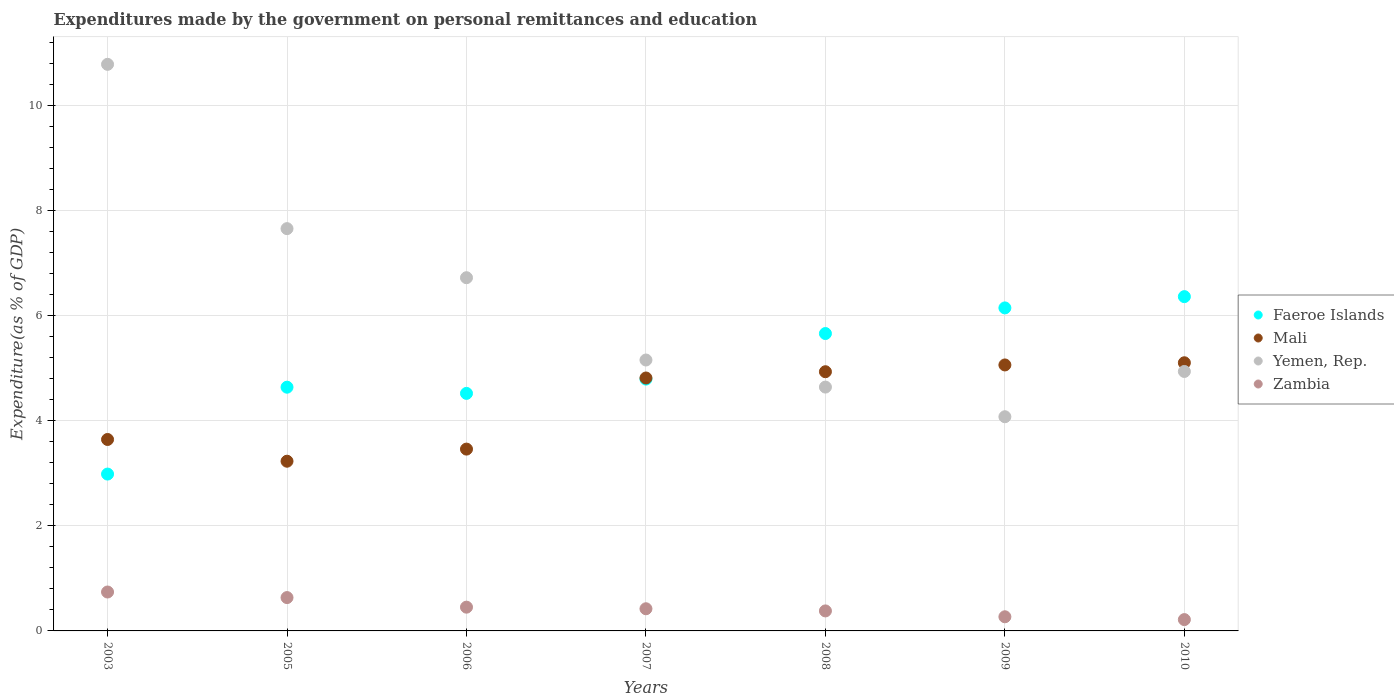Is the number of dotlines equal to the number of legend labels?
Ensure brevity in your answer.  Yes. What is the expenditures made by the government on personal remittances and education in Faeroe Islands in 2010?
Your answer should be very brief. 6.36. Across all years, what is the maximum expenditures made by the government on personal remittances and education in Faeroe Islands?
Give a very brief answer. 6.36. Across all years, what is the minimum expenditures made by the government on personal remittances and education in Zambia?
Make the answer very short. 0.22. In which year was the expenditures made by the government on personal remittances and education in Zambia minimum?
Provide a short and direct response. 2010. What is the total expenditures made by the government on personal remittances and education in Faeroe Islands in the graph?
Offer a terse response. 35.1. What is the difference between the expenditures made by the government on personal remittances and education in Zambia in 2009 and that in 2010?
Keep it short and to the point. 0.05. What is the difference between the expenditures made by the government on personal remittances and education in Faeroe Islands in 2006 and the expenditures made by the government on personal remittances and education in Mali in 2008?
Ensure brevity in your answer.  -0.41. What is the average expenditures made by the government on personal remittances and education in Faeroe Islands per year?
Make the answer very short. 5.01. In the year 2009, what is the difference between the expenditures made by the government on personal remittances and education in Faeroe Islands and expenditures made by the government on personal remittances and education in Yemen, Rep.?
Keep it short and to the point. 2.07. In how many years, is the expenditures made by the government on personal remittances and education in Yemen, Rep. greater than 0.4 %?
Give a very brief answer. 7. What is the ratio of the expenditures made by the government on personal remittances and education in Mali in 2008 to that in 2009?
Provide a succinct answer. 0.97. Is the expenditures made by the government on personal remittances and education in Mali in 2007 less than that in 2008?
Offer a terse response. Yes. Is the difference between the expenditures made by the government on personal remittances and education in Faeroe Islands in 2003 and 2006 greater than the difference between the expenditures made by the government on personal remittances and education in Yemen, Rep. in 2003 and 2006?
Keep it short and to the point. No. What is the difference between the highest and the second highest expenditures made by the government on personal remittances and education in Yemen, Rep.?
Your answer should be very brief. 3.13. What is the difference between the highest and the lowest expenditures made by the government on personal remittances and education in Yemen, Rep.?
Provide a succinct answer. 6.71. Is it the case that in every year, the sum of the expenditures made by the government on personal remittances and education in Mali and expenditures made by the government on personal remittances and education in Yemen, Rep.  is greater than the sum of expenditures made by the government on personal remittances and education in Faeroe Islands and expenditures made by the government on personal remittances and education in Zambia?
Provide a short and direct response. No. Is it the case that in every year, the sum of the expenditures made by the government on personal remittances and education in Faeroe Islands and expenditures made by the government on personal remittances and education in Zambia  is greater than the expenditures made by the government on personal remittances and education in Yemen, Rep.?
Keep it short and to the point. No. Does the expenditures made by the government on personal remittances and education in Mali monotonically increase over the years?
Make the answer very short. No. Is the expenditures made by the government on personal remittances and education in Faeroe Islands strictly greater than the expenditures made by the government on personal remittances and education in Zambia over the years?
Provide a short and direct response. Yes. How many dotlines are there?
Provide a succinct answer. 4. How many years are there in the graph?
Give a very brief answer. 7. What is the difference between two consecutive major ticks on the Y-axis?
Provide a succinct answer. 2. Does the graph contain any zero values?
Your response must be concise. No. Where does the legend appear in the graph?
Provide a short and direct response. Center right. How are the legend labels stacked?
Make the answer very short. Vertical. What is the title of the graph?
Make the answer very short. Expenditures made by the government on personal remittances and education. Does "Netherlands" appear as one of the legend labels in the graph?
Your answer should be compact. No. What is the label or title of the X-axis?
Provide a short and direct response. Years. What is the label or title of the Y-axis?
Keep it short and to the point. Expenditure(as % of GDP). What is the Expenditure(as % of GDP) of Faeroe Islands in 2003?
Give a very brief answer. 2.98. What is the Expenditure(as % of GDP) of Mali in 2003?
Your answer should be very brief. 3.64. What is the Expenditure(as % of GDP) of Yemen, Rep. in 2003?
Provide a short and direct response. 10.78. What is the Expenditure(as % of GDP) in Zambia in 2003?
Your answer should be compact. 0.74. What is the Expenditure(as % of GDP) of Faeroe Islands in 2005?
Offer a very short reply. 4.64. What is the Expenditure(as % of GDP) in Mali in 2005?
Offer a terse response. 3.23. What is the Expenditure(as % of GDP) of Yemen, Rep. in 2005?
Your answer should be compact. 7.66. What is the Expenditure(as % of GDP) in Zambia in 2005?
Provide a short and direct response. 0.63. What is the Expenditure(as % of GDP) of Faeroe Islands in 2006?
Keep it short and to the point. 4.52. What is the Expenditure(as % of GDP) in Mali in 2006?
Ensure brevity in your answer.  3.46. What is the Expenditure(as % of GDP) of Yemen, Rep. in 2006?
Offer a terse response. 6.72. What is the Expenditure(as % of GDP) of Zambia in 2006?
Provide a succinct answer. 0.45. What is the Expenditure(as % of GDP) of Faeroe Islands in 2007?
Provide a succinct answer. 4.79. What is the Expenditure(as % of GDP) of Mali in 2007?
Ensure brevity in your answer.  4.81. What is the Expenditure(as % of GDP) in Yemen, Rep. in 2007?
Your answer should be very brief. 5.16. What is the Expenditure(as % of GDP) of Zambia in 2007?
Ensure brevity in your answer.  0.42. What is the Expenditure(as % of GDP) of Faeroe Islands in 2008?
Offer a very short reply. 5.66. What is the Expenditure(as % of GDP) in Mali in 2008?
Give a very brief answer. 4.93. What is the Expenditure(as % of GDP) in Yemen, Rep. in 2008?
Make the answer very short. 4.64. What is the Expenditure(as % of GDP) in Zambia in 2008?
Give a very brief answer. 0.38. What is the Expenditure(as % of GDP) of Faeroe Islands in 2009?
Your answer should be compact. 6.15. What is the Expenditure(as % of GDP) in Mali in 2009?
Provide a short and direct response. 5.06. What is the Expenditure(as % of GDP) in Yemen, Rep. in 2009?
Make the answer very short. 4.08. What is the Expenditure(as % of GDP) in Zambia in 2009?
Give a very brief answer. 0.27. What is the Expenditure(as % of GDP) of Faeroe Islands in 2010?
Offer a very short reply. 6.36. What is the Expenditure(as % of GDP) of Mali in 2010?
Keep it short and to the point. 5.1. What is the Expenditure(as % of GDP) in Yemen, Rep. in 2010?
Give a very brief answer. 4.94. What is the Expenditure(as % of GDP) in Zambia in 2010?
Your answer should be very brief. 0.22. Across all years, what is the maximum Expenditure(as % of GDP) in Faeroe Islands?
Offer a very short reply. 6.36. Across all years, what is the maximum Expenditure(as % of GDP) of Mali?
Your response must be concise. 5.1. Across all years, what is the maximum Expenditure(as % of GDP) of Yemen, Rep.?
Make the answer very short. 10.78. Across all years, what is the maximum Expenditure(as % of GDP) in Zambia?
Make the answer very short. 0.74. Across all years, what is the minimum Expenditure(as % of GDP) of Faeroe Islands?
Your answer should be compact. 2.98. Across all years, what is the minimum Expenditure(as % of GDP) of Mali?
Your answer should be very brief. 3.23. Across all years, what is the minimum Expenditure(as % of GDP) in Yemen, Rep.?
Ensure brevity in your answer.  4.08. Across all years, what is the minimum Expenditure(as % of GDP) in Zambia?
Offer a very short reply. 0.22. What is the total Expenditure(as % of GDP) in Faeroe Islands in the graph?
Offer a terse response. 35.1. What is the total Expenditure(as % of GDP) in Mali in the graph?
Offer a very short reply. 30.24. What is the total Expenditure(as % of GDP) in Yemen, Rep. in the graph?
Offer a very short reply. 43.97. What is the total Expenditure(as % of GDP) of Zambia in the graph?
Offer a very short reply. 3.11. What is the difference between the Expenditure(as % of GDP) in Faeroe Islands in 2003 and that in 2005?
Offer a very short reply. -1.65. What is the difference between the Expenditure(as % of GDP) in Mali in 2003 and that in 2005?
Your answer should be compact. 0.41. What is the difference between the Expenditure(as % of GDP) in Yemen, Rep. in 2003 and that in 2005?
Your answer should be compact. 3.13. What is the difference between the Expenditure(as % of GDP) of Zambia in 2003 and that in 2005?
Your answer should be very brief. 0.11. What is the difference between the Expenditure(as % of GDP) of Faeroe Islands in 2003 and that in 2006?
Keep it short and to the point. -1.54. What is the difference between the Expenditure(as % of GDP) of Mali in 2003 and that in 2006?
Make the answer very short. 0.18. What is the difference between the Expenditure(as % of GDP) in Yemen, Rep. in 2003 and that in 2006?
Give a very brief answer. 4.06. What is the difference between the Expenditure(as % of GDP) of Zambia in 2003 and that in 2006?
Give a very brief answer. 0.29. What is the difference between the Expenditure(as % of GDP) of Faeroe Islands in 2003 and that in 2007?
Provide a succinct answer. -1.81. What is the difference between the Expenditure(as % of GDP) in Mali in 2003 and that in 2007?
Give a very brief answer. -1.17. What is the difference between the Expenditure(as % of GDP) of Yemen, Rep. in 2003 and that in 2007?
Give a very brief answer. 5.63. What is the difference between the Expenditure(as % of GDP) in Zambia in 2003 and that in 2007?
Provide a succinct answer. 0.32. What is the difference between the Expenditure(as % of GDP) in Faeroe Islands in 2003 and that in 2008?
Give a very brief answer. -2.67. What is the difference between the Expenditure(as % of GDP) in Mali in 2003 and that in 2008?
Your answer should be very brief. -1.29. What is the difference between the Expenditure(as % of GDP) of Yemen, Rep. in 2003 and that in 2008?
Your response must be concise. 6.14. What is the difference between the Expenditure(as % of GDP) in Zambia in 2003 and that in 2008?
Provide a succinct answer. 0.36. What is the difference between the Expenditure(as % of GDP) in Faeroe Islands in 2003 and that in 2009?
Ensure brevity in your answer.  -3.16. What is the difference between the Expenditure(as % of GDP) of Mali in 2003 and that in 2009?
Give a very brief answer. -1.42. What is the difference between the Expenditure(as % of GDP) of Yemen, Rep. in 2003 and that in 2009?
Offer a very short reply. 6.71. What is the difference between the Expenditure(as % of GDP) in Zambia in 2003 and that in 2009?
Offer a terse response. 0.47. What is the difference between the Expenditure(as % of GDP) of Faeroe Islands in 2003 and that in 2010?
Give a very brief answer. -3.38. What is the difference between the Expenditure(as % of GDP) of Mali in 2003 and that in 2010?
Ensure brevity in your answer.  -1.46. What is the difference between the Expenditure(as % of GDP) in Yemen, Rep. in 2003 and that in 2010?
Offer a terse response. 5.84. What is the difference between the Expenditure(as % of GDP) of Zambia in 2003 and that in 2010?
Offer a terse response. 0.53. What is the difference between the Expenditure(as % of GDP) in Faeroe Islands in 2005 and that in 2006?
Offer a very short reply. 0.12. What is the difference between the Expenditure(as % of GDP) in Mali in 2005 and that in 2006?
Ensure brevity in your answer.  -0.23. What is the difference between the Expenditure(as % of GDP) of Yemen, Rep. in 2005 and that in 2006?
Offer a terse response. 0.93. What is the difference between the Expenditure(as % of GDP) in Zambia in 2005 and that in 2006?
Your answer should be compact. 0.18. What is the difference between the Expenditure(as % of GDP) of Faeroe Islands in 2005 and that in 2007?
Your answer should be very brief. -0.15. What is the difference between the Expenditure(as % of GDP) in Mali in 2005 and that in 2007?
Offer a terse response. -1.58. What is the difference between the Expenditure(as % of GDP) in Yemen, Rep. in 2005 and that in 2007?
Offer a very short reply. 2.5. What is the difference between the Expenditure(as % of GDP) of Zambia in 2005 and that in 2007?
Make the answer very short. 0.21. What is the difference between the Expenditure(as % of GDP) of Faeroe Islands in 2005 and that in 2008?
Offer a very short reply. -1.02. What is the difference between the Expenditure(as % of GDP) in Mali in 2005 and that in 2008?
Offer a terse response. -1.7. What is the difference between the Expenditure(as % of GDP) of Yemen, Rep. in 2005 and that in 2008?
Give a very brief answer. 3.02. What is the difference between the Expenditure(as % of GDP) in Zambia in 2005 and that in 2008?
Offer a very short reply. 0.25. What is the difference between the Expenditure(as % of GDP) of Faeroe Islands in 2005 and that in 2009?
Ensure brevity in your answer.  -1.51. What is the difference between the Expenditure(as % of GDP) in Mali in 2005 and that in 2009?
Offer a terse response. -1.83. What is the difference between the Expenditure(as % of GDP) in Yemen, Rep. in 2005 and that in 2009?
Make the answer very short. 3.58. What is the difference between the Expenditure(as % of GDP) of Zambia in 2005 and that in 2009?
Make the answer very short. 0.37. What is the difference between the Expenditure(as % of GDP) in Faeroe Islands in 2005 and that in 2010?
Your answer should be compact. -1.72. What is the difference between the Expenditure(as % of GDP) of Mali in 2005 and that in 2010?
Give a very brief answer. -1.87. What is the difference between the Expenditure(as % of GDP) of Yemen, Rep. in 2005 and that in 2010?
Ensure brevity in your answer.  2.72. What is the difference between the Expenditure(as % of GDP) of Zambia in 2005 and that in 2010?
Your answer should be compact. 0.42. What is the difference between the Expenditure(as % of GDP) of Faeroe Islands in 2006 and that in 2007?
Keep it short and to the point. -0.27. What is the difference between the Expenditure(as % of GDP) of Mali in 2006 and that in 2007?
Offer a very short reply. -1.35. What is the difference between the Expenditure(as % of GDP) in Yemen, Rep. in 2006 and that in 2007?
Give a very brief answer. 1.57. What is the difference between the Expenditure(as % of GDP) in Zambia in 2006 and that in 2007?
Your answer should be very brief. 0.03. What is the difference between the Expenditure(as % of GDP) of Faeroe Islands in 2006 and that in 2008?
Give a very brief answer. -1.14. What is the difference between the Expenditure(as % of GDP) in Mali in 2006 and that in 2008?
Provide a short and direct response. -1.47. What is the difference between the Expenditure(as % of GDP) of Yemen, Rep. in 2006 and that in 2008?
Your response must be concise. 2.08. What is the difference between the Expenditure(as % of GDP) of Zambia in 2006 and that in 2008?
Offer a terse response. 0.07. What is the difference between the Expenditure(as % of GDP) of Faeroe Islands in 2006 and that in 2009?
Provide a succinct answer. -1.63. What is the difference between the Expenditure(as % of GDP) in Mali in 2006 and that in 2009?
Your answer should be very brief. -1.6. What is the difference between the Expenditure(as % of GDP) in Yemen, Rep. in 2006 and that in 2009?
Ensure brevity in your answer.  2.65. What is the difference between the Expenditure(as % of GDP) of Zambia in 2006 and that in 2009?
Your response must be concise. 0.18. What is the difference between the Expenditure(as % of GDP) in Faeroe Islands in 2006 and that in 2010?
Ensure brevity in your answer.  -1.84. What is the difference between the Expenditure(as % of GDP) of Mali in 2006 and that in 2010?
Ensure brevity in your answer.  -1.64. What is the difference between the Expenditure(as % of GDP) in Yemen, Rep. in 2006 and that in 2010?
Your answer should be very brief. 1.78. What is the difference between the Expenditure(as % of GDP) of Zambia in 2006 and that in 2010?
Provide a short and direct response. 0.24. What is the difference between the Expenditure(as % of GDP) of Faeroe Islands in 2007 and that in 2008?
Ensure brevity in your answer.  -0.87. What is the difference between the Expenditure(as % of GDP) in Mali in 2007 and that in 2008?
Offer a terse response. -0.12. What is the difference between the Expenditure(as % of GDP) in Yemen, Rep. in 2007 and that in 2008?
Ensure brevity in your answer.  0.52. What is the difference between the Expenditure(as % of GDP) of Zambia in 2007 and that in 2008?
Give a very brief answer. 0.04. What is the difference between the Expenditure(as % of GDP) in Faeroe Islands in 2007 and that in 2009?
Your answer should be very brief. -1.35. What is the difference between the Expenditure(as % of GDP) of Mali in 2007 and that in 2009?
Ensure brevity in your answer.  -0.25. What is the difference between the Expenditure(as % of GDP) of Yemen, Rep. in 2007 and that in 2009?
Your answer should be very brief. 1.08. What is the difference between the Expenditure(as % of GDP) of Zambia in 2007 and that in 2009?
Ensure brevity in your answer.  0.15. What is the difference between the Expenditure(as % of GDP) in Faeroe Islands in 2007 and that in 2010?
Provide a short and direct response. -1.57. What is the difference between the Expenditure(as % of GDP) in Mali in 2007 and that in 2010?
Provide a succinct answer. -0.29. What is the difference between the Expenditure(as % of GDP) of Yemen, Rep. in 2007 and that in 2010?
Your answer should be very brief. 0.22. What is the difference between the Expenditure(as % of GDP) in Zambia in 2007 and that in 2010?
Make the answer very short. 0.21. What is the difference between the Expenditure(as % of GDP) of Faeroe Islands in 2008 and that in 2009?
Ensure brevity in your answer.  -0.49. What is the difference between the Expenditure(as % of GDP) in Mali in 2008 and that in 2009?
Give a very brief answer. -0.13. What is the difference between the Expenditure(as % of GDP) in Yemen, Rep. in 2008 and that in 2009?
Provide a succinct answer. 0.56. What is the difference between the Expenditure(as % of GDP) in Zambia in 2008 and that in 2009?
Offer a terse response. 0.11. What is the difference between the Expenditure(as % of GDP) in Faeroe Islands in 2008 and that in 2010?
Ensure brevity in your answer.  -0.7. What is the difference between the Expenditure(as % of GDP) in Mali in 2008 and that in 2010?
Provide a succinct answer. -0.17. What is the difference between the Expenditure(as % of GDP) of Yemen, Rep. in 2008 and that in 2010?
Your response must be concise. -0.3. What is the difference between the Expenditure(as % of GDP) of Zambia in 2008 and that in 2010?
Provide a short and direct response. 0.17. What is the difference between the Expenditure(as % of GDP) in Faeroe Islands in 2009 and that in 2010?
Give a very brief answer. -0.21. What is the difference between the Expenditure(as % of GDP) in Mali in 2009 and that in 2010?
Keep it short and to the point. -0.04. What is the difference between the Expenditure(as % of GDP) of Yemen, Rep. in 2009 and that in 2010?
Provide a succinct answer. -0.86. What is the difference between the Expenditure(as % of GDP) in Zambia in 2009 and that in 2010?
Ensure brevity in your answer.  0.05. What is the difference between the Expenditure(as % of GDP) of Faeroe Islands in 2003 and the Expenditure(as % of GDP) of Mali in 2005?
Provide a succinct answer. -0.24. What is the difference between the Expenditure(as % of GDP) of Faeroe Islands in 2003 and the Expenditure(as % of GDP) of Yemen, Rep. in 2005?
Offer a very short reply. -4.67. What is the difference between the Expenditure(as % of GDP) in Faeroe Islands in 2003 and the Expenditure(as % of GDP) in Zambia in 2005?
Keep it short and to the point. 2.35. What is the difference between the Expenditure(as % of GDP) of Mali in 2003 and the Expenditure(as % of GDP) of Yemen, Rep. in 2005?
Your answer should be compact. -4.01. What is the difference between the Expenditure(as % of GDP) in Mali in 2003 and the Expenditure(as % of GDP) in Zambia in 2005?
Offer a terse response. 3.01. What is the difference between the Expenditure(as % of GDP) in Yemen, Rep. in 2003 and the Expenditure(as % of GDP) in Zambia in 2005?
Your answer should be compact. 10.15. What is the difference between the Expenditure(as % of GDP) of Faeroe Islands in 2003 and the Expenditure(as % of GDP) of Mali in 2006?
Ensure brevity in your answer.  -0.48. What is the difference between the Expenditure(as % of GDP) in Faeroe Islands in 2003 and the Expenditure(as % of GDP) in Yemen, Rep. in 2006?
Give a very brief answer. -3.74. What is the difference between the Expenditure(as % of GDP) in Faeroe Islands in 2003 and the Expenditure(as % of GDP) in Zambia in 2006?
Make the answer very short. 2.53. What is the difference between the Expenditure(as % of GDP) in Mali in 2003 and the Expenditure(as % of GDP) in Yemen, Rep. in 2006?
Keep it short and to the point. -3.08. What is the difference between the Expenditure(as % of GDP) of Mali in 2003 and the Expenditure(as % of GDP) of Zambia in 2006?
Give a very brief answer. 3.19. What is the difference between the Expenditure(as % of GDP) in Yemen, Rep. in 2003 and the Expenditure(as % of GDP) in Zambia in 2006?
Keep it short and to the point. 10.33. What is the difference between the Expenditure(as % of GDP) of Faeroe Islands in 2003 and the Expenditure(as % of GDP) of Mali in 2007?
Your response must be concise. -1.83. What is the difference between the Expenditure(as % of GDP) of Faeroe Islands in 2003 and the Expenditure(as % of GDP) of Yemen, Rep. in 2007?
Your answer should be very brief. -2.17. What is the difference between the Expenditure(as % of GDP) in Faeroe Islands in 2003 and the Expenditure(as % of GDP) in Zambia in 2007?
Provide a short and direct response. 2.56. What is the difference between the Expenditure(as % of GDP) of Mali in 2003 and the Expenditure(as % of GDP) of Yemen, Rep. in 2007?
Offer a very short reply. -1.51. What is the difference between the Expenditure(as % of GDP) in Mali in 2003 and the Expenditure(as % of GDP) in Zambia in 2007?
Your response must be concise. 3.22. What is the difference between the Expenditure(as % of GDP) of Yemen, Rep. in 2003 and the Expenditure(as % of GDP) of Zambia in 2007?
Your response must be concise. 10.36. What is the difference between the Expenditure(as % of GDP) of Faeroe Islands in 2003 and the Expenditure(as % of GDP) of Mali in 2008?
Offer a terse response. -1.95. What is the difference between the Expenditure(as % of GDP) in Faeroe Islands in 2003 and the Expenditure(as % of GDP) in Yemen, Rep. in 2008?
Offer a terse response. -1.66. What is the difference between the Expenditure(as % of GDP) in Faeroe Islands in 2003 and the Expenditure(as % of GDP) in Zambia in 2008?
Provide a short and direct response. 2.6. What is the difference between the Expenditure(as % of GDP) in Mali in 2003 and the Expenditure(as % of GDP) in Yemen, Rep. in 2008?
Provide a succinct answer. -1. What is the difference between the Expenditure(as % of GDP) of Mali in 2003 and the Expenditure(as % of GDP) of Zambia in 2008?
Provide a short and direct response. 3.26. What is the difference between the Expenditure(as % of GDP) of Yemen, Rep. in 2003 and the Expenditure(as % of GDP) of Zambia in 2008?
Ensure brevity in your answer.  10.4. What is the difference between the Expenditure(as % of GDP) of Faeroe Islands in 2003 and the Expenditure(as % of GDP) of Mali in 2009?
Make the answer very short. -2.08. What is the difference between the Expenditure(as % of GDP) in Faeroe Islands in 2003 and the Expenditure(as % of GDP) in Yemen, Rep. in 2009?
Provide a short and direct response. -1.09. What is the difference between the Expenditure(as % of GDP) in Faeroe Islands in 2003 and the Expenditure(as % of GDP) in Zambia in 2009?
Provide a succinct answer. 2.72. What is the difference between the Expenditure(as % of GDP) of Mali in 2003 and the Expenditure(as % of GDP) of Yemen, Rep. in 2009?
Give a very brief answer. -0.43. What is the difference between the Expenditure(as % of GDP) in Mali in 2003 and the Expenditure(as % of GDP) in Zambia in 2009?
Ensure brevity in your answer.  3.37. What is the difference between the Expenditure(as % of GDP) of Yemen, Rep. in 2003 and the Expenditure(as % of GDP) of Zambia in 2009?
Provide a short and direct response. 10.51. What is the difference between the Expenditure(as % of GDP) of Faeroe Islands in 2003 and the Expenditure(as % of GDP) of Mali in 2010?
Offer a terse response. -2.12. What is the difference between the Expenditure(as % of GDP) of Faeroe Islands in 2003 and the Expenditure(as % of GDP) of Yemen, Rep. in 2010?
Give a very brief answer. -1.95. What is the difference between the Expenditure(as % of GDP) in Faeroe Islands in 2003 and the Expenditure(as % of GDP) in Zambia in 2010?
Offer a very short reply. 2.77. What is the difference between the Expenditure(as % of GDP) of Mali in 2003 and the Expenditure(as % of GDP) of Yemen, Rep. in 2010?
Offer a very short reply. -1.29. What is the difference between the Expenditure(as % of GDP) in Mali in 2003 and the Expenditure(as % of GDP) in Zambia in 2010?
Keep it short and to the point. 3.43. What is the difference between the Expenditure(as % of GDP) in Yemen, Rep. in 2003 and the Expenditure(as % of GDP) in Zambia in 2010?
Your answer should be very brief. 10.57. What is the difference between the Expenditure(as % of GDP) of Faeroe Islands in 2005 and the Expenditure(as % of GDP) of Mali in 2006?
Your answer should be compact. 1.18. What is the difference between the Expenditure(as % of GDP) of Faeroe Islands in 2005 and the Expenditure(as % of GDP) of Yemen, Rep. in 2006?
Ensure brevity in your answer.  -2.08. What is the difference between the Expenditure(as % of GDP) in Faeroe Islands in 2005 and the Expenditure(as % of GDP) in Zambia in 2006?
Your answer should be compact. 4.19. What is the difference between the Expenditure(as % of GDP) of Mali in 2005 and the Expenditure(as % of GDP) of Yemen, Rep. in 2006?
Offer a terse response. -3.49. What is the difference between the Expenditure(as % of GDP) of Mali in 2005 and the Expenditure(as % of GDP) of Zambia in 2006?
Make the answer very short. 2.78. What is the difference between the Expenditure(as % of GDP) in Yemen, Rep. in 2005 and the Expenditure(as % of GDP) in Zambia in 2006?
Offer a terse response. 7.2. What is the difference between the Expenditure(as % of GDP) in Faeroe Islands in 2005 and the Expenditure(as % of GDP) in Mali in 2007?
Keep it short and to the point. -0.17. What is the difference between the Expenditure(as % of GDP) of Faeroe Islands in 2005 and the Expenditure(as % of GDP) of Yemen, Rep. in 2007?
Make the answer very short. -0.52. What is the difference between the Expenditure(as % of GDP) in Faeroe Islands in 2005 and the Expenditure(as % of GDP) in Zambia in 2007?
Your response must be concise. 4.22. What is the difference between the Expenditure(as % of GDP) of Mali in 2005 and the Expenditure(as % of GDP) of Yemen, Rep. in 2007?
Keep it short and to the point. -1.93. What is the difference between the Expenditure(as % of GDP) of Mali in 2005 and the Expenditure(as % of GDP) of Zambia in 2007?
Your response must be concise. 2.81. What is the difference between the Expenditure(as % of GDP) in Yemen, Rep. in 2005 and the Expenditure(as % of GDP) in Zambia in 2007?
Ensure brevity in your answer.  7.23. What is the difference between the Expenditure(as % of GDP) of Faeroe Islands in 2005 and the Expenditure(as % of GDP) of Mali in 2008?
Your answer should be compact. -0.29. What is the difference between the Expenditure(as % of GDP) in Faeroe Islands in 2005 and the Expenditure(as % of GDP) in Yemen, Rep. in 2008?
Provide a short and direct response. -0. What is the difference between the Expenditure(as % of GDP) in Faeroe Islands in 2005 and the Expenditure(as % of GDP) in Zambia in 2008?
Make the answer very short. 4.26. What is the difference between the Expenditure(as % of GDP) in Mali in 2005 and the Expenditure(as % of GDP) in Yemen, Rep. in 2008?
Provide a short and direct response. -1.41. What is the difference between the Expenditure(as % of GDP) of Mali in 2005 and the Expenditure(as % of GDP) of Zambia in 2008?
Offer a very short reply. 2.85. What is the difference between the Expenditure(as % of GDP) in Yemen, Rep. in 2005 and the Expenditure(as % of GDP) in Zambia in 2008?
Provide a succinct answer. 7.27. What is the difference between the Expenditure(as % of GDP) of Faeroe Islands in 2005 and the Expenditure(as % of GDP) of Mali in 2009?
Your answer should be compact. -0.42. What is the difference between the Expenditure(as % of GDP) in Faeroe Islands in 2005 and the Expenditure(as % of GDP) in Yemen, Rep. in 2009?
Offer a very short reply. 0.56. What is the difference between the Expenditure(as % of GDP) in Faeroe Islands in 2005 and the Expenditure(as % of GDP) in Zambia in 2009?
Offer a very short reply. 4.37. What is the difference between the Expenditure(as % of GDP) of Mali in 2005 and the Expenditure(as % of GDP) of Yemen, Rep. in 2009?
Keep it short and to the point. -0.85. What is the difference between the Expenditure(as % of GDP) in Mali in 2005 and the Expenditure(as % of GDP) in Zambia in 2009?
Offer a very short reply. 2.96. What is the difference between the Expenditure(as % of GDP) in Yemen, Rep. in 2005 and the Expenditure(as % of GDP) in Zambia in 2009?
Keep it short and to the point. 7.39. What is the difference between the Expenditure(as % of GDP) in Faeroe Islands in 2005 and the Expenditure(as % of GDP) in Mali in 2010?
Make the answer very short. -0.46. What is the difference between the Expenditure(as % of GDP) in Faeroe Islands in 2005 and the Expenditure(as % of GDP) in Yemen, Rep. in 2010?
Provide a succinct answer. -0.3. What is the difference between the Expenditure(as % of GDP) of Faeroe Islands in 2005 and the Expenditure(as % of GDP) of Zambia in 2010?
Provide a short and direct response. 4.42. What is the difference between the Expenditure(as % of GDP) in Mali in 2005 and the Expenditure(as % of GDP) in Yemen, Rep. in 2010?
Offer a terse response. -1.71. What is the difference between the Expenditure(as % of GDP) in Mali in 2005 and the Expenditure(as % of GDP) in Zambia in 2010?
Offer a terse response. 3.01. What is the difference between the Expenditure(as % of GDP) in Yemen, Rep. in 2005 and the Expenditure(as % of GDP) in Zambia in 2010?
Offer a very short reply. 7.44. What is the difference between the Expenditure(as % of GDP) in Faeroe Islands in 2006 and the Expenditure(as % of GDP) in Mali in 2007?
Provide a succinct answer. -0.29. What is the difference between the Expenditure(as % of GDP) of Faeroe Islands in 2006 and the Expenditure(as % of GDP) of Yemen, Rep. in 2007?
Ensure brevity in your answer.  -0.64. What is the difference between the Expenditure(as % of GDP) of Faeroe Islands in 2006 and the Expenditure(as % of GDP) of Zambia in 2007?
Offer a terse response. 4.1. What is the difference between the Expenditure(as % of GDP) in Mali in 2006 and the Expenditure(as % of GDP) in Yemen, Rep. in 2007?
Make the answer very short. -1.7. What is the difference between the Expenditure(as % of GDP) of Mali in 2006 and the Expenditure(as % of GDP) of Zambia in 2007?
Offer a terse response. 3.04. What is the difference between the Expenditure(as % of GDP) in Yemen, Rep. in 2006 and the Expenditure(as % of GDP) in Zambia in 2007?
Offer a terse response. 6.3. What is the difference between the Expenditure(as % of GDP) of Faeroe Islands in 2006 and the Expenditure(as % of GDP) of Mali in 2008?
Your answer should be compact. -0.41. What is the difference between the Expenditure(as % of GDP) of Faeroe Islands in 2006 and the Expenditure(as % of GDP) of Yemen, Rep. in 2008?
Your answer should be very brief. -0.12. What is the difference between the Expenditure(as % of GDP) of Faeroe Islands in 2006 and the Expenditure(as % of GDP) of Zambia in 2008?
Provide a succinct answer. 4.14. What is the difference between the Expenditure(as % of GDP) in Mali in 2006 and the Expenditure(as % of GDP) in Yemen, Rep. in 2008?
Offer a very short reply. -1.18. What is the difference between the Expenditure(as % of GDP) in Mali in 2006 and the Expenditure(as % of GDP) in Zambia in 2008?
Your answer should be compact. 3.08. What is the difference between the Expenditure(as % of GDP) in Yemen, Rep. in 2006 and the Expenditure(as % of GDP) in Zambia in 2008?
Your response must be concise. 6.34. What is the difference between the Expenditure(as % of GDP) in Faeroe Islands in 2006 and the Expenditure(as % of GDP) in Mali in 2009?
Your answer should be very brief. -0.54. What is the difference between the Expenditure(as % of GDP) of Faeroe Islands in 2006 and the Expenditure(as % of GDP) of Yemen, Rep. in 2009?
Your answer should be very brief. 0.44. What is the difference between the Expenditure(as % of GDP) of Faeroe Islands in 2006 and the Expenditure(as % of GDP) of Zambia in 2009?
Ensure brevity in your answer.  4.25. What is the difference between the Expenditure(as % of GDP) of Mali in 2006 and the Expenditure(as % of GDP) of Yemen, Rep. in 2009?
Offer a terse response. -0.62. What is the difference between the Expenditure(as % of GDP) in Mali in 2006 and the Expenditure(as % of GDP) in Zambia in 2009?
Offer a very short reply. 3.19. What is the difference between the Expenditure(as % of GDP) of Yemen, Rep. in 2006 and the Expenditure(as % of GDP) of Zambia in 2009?
Keep it short and to the point. 6.45. What is the difference between the Expenditure(as % of GDP) in Faeroe Islands in 2006 and the Expenditure(as % of GDP) in Mali in 2010?
Your answer should be very brief. -0.58. What is the difference between the Expenditure(as % of GDP) of Faeroe Islands in 2006 and the Expenditure(as % of GDP) of Yemen, Rep. in 2010?
Provide a short and direct response. -0.42. What is the difference between the Expenditure(as % of GDP) in Faeroe Islands in 2006 and the Expenditure(as % of GDP) in Zambia in 2010?
Give a very brief answer. 4.3. What is the difference between the Expenditure(as % of GDP) in Mali in 2006 and the Expenditure(as % of GDP) in Yemen, Rep. in 2010?
Your response must be concise. -1.48. What is the difference between the Expenditure(as % of GDP) in Mali in 2006 and the Expenditure(as % of GDP) in Zambia in 2010?
Offer a terse response. 3.24. What is the difference between the Expenditure(as % of GDP) in Yemen, Rep. in 2006 and the Expenditure(as % of GDP) in Zambia in 2010?
Give a very brief answer. 6.51. What is the difference between the Expenditure(as % of GDP) in Faeroe Islands in 2007 and the Expenditure(as % of GDP) in Mali in 2008?
Offer a terse response. -0.14. What is the difference between the Expenditure(as % of GDP) of Faeroe Islands in 2007 and the Expenditure(as % of GDP) of Yemen, Rep. in 2008?
Your answer should be very brief. 0.15. What is the difference between the Expenditure(as % of GDP) in Faeroe Islands in 2007 and the Expenditure(as % of GDP) in Zambia in 2008?
Your answer should be very brief. 4.41. What is the difference between the Expenditure(as % of GDP) in Mali in 2007 and the Expenditure(as % of GDP) in Yemen, Rep. in 2008?
Offer a terse response. 0.17. What is the difference between the Expenditure(as % of GDP) in Mali in 2007 and the Expenditure(as % of GDP) in Zambia in 2008?
Make the answer very short. 4.43. What is the difference between the Expenditure(as % of GDP) of Yemen, Rep. in 2007 and the Expenditure(as % of GDP) of Zambia in 2008?
Provide a succinct answer. 4.77. What is the difference between the Expenditure(as % of GDP) in Faeroe Islands in 2007 and the Expenditure(as % of GDP) in Mali in 2009?
Make the answer very short. -0.27. What is the difference between the Expenditure(as % of GDP) of Faeroe Islands in 2007 and the Expenditure(as % of GDP) of Yemen, Rep. in 2009?
Provide a succinct answer. 0.72. What is the difference between the Expenditure(as % of GDP) in Faeroe Islands in 2007 and the Expenditure(as % of GDP) in Zambia in 2009?
Make the answer very short. 4.52. What is the difference between the Expenditure(as % of GDP) of Mali in 2007 and the Expenditure(as % of GDP) of Yemen, Rep. in 2009?
Offer a terse response. 0.74. What is the difference between the Expenditure(as % of GDP) in Mali in 2007 and the Expenditure(as % of GDP) in Zambia in 2009?
Make the answer very short. 4.54. What is the difference between the Expenditure(as % of GDP) in Yemen, Rep. in 2007 and the Expenditure(as % of GDP) in Zambia in 2009?
Keep it short and to the point. 4.89. What is the difference between the Expenditure(as % of GDP) of Faeroe Islands in 2007 and the Expenditure(as % of GDP) of Mali in 2010?
Give a very brief answer. -0.31. What is the difference between the Expenditure(as % of GDP) in Faeroe Islands in 2007 and the Expenditure(as % of GDP) in Yemen, Rep. in 2010?
Your answer should be compact. -0.15. What is the difference between the Expenditure(as % of GDP) of Faeroe Islands in 2007 and the Expenditure(as % of GDP) of Zambia in 2010?
Keep it short and to the point. 4.58. What is the difference between the Expenditure(as % of GDP) of Mali in 2007 and the Expenditure(as % of GDP) of Yemen, Rep. in 2010?
Offer a very short reply. -0.12. What is the difference between the Expenditure(as % of GDP) in Mali in 2007 and the Expenditure(as % of GDP) in Zambia in 2010?
Keep it short and to the point. 4.6. What is the difference between the Expenditure(as % of GDP) of Yemen, Rep. in 2007 and the Expenditure(as % of GDP) of Zambia in 2010?
Your answer should be very brief. 4.94. What is the difference between the Expenditure(as % of GDP) of Faeroe Islands in 2008 and the Expenditure(as % of GDP) of Mali in 2009?
Your response must be concise. 0.6. What is the difference between the Expenditure(as % of GDP) of Faeroe Islands in 2008 and the Expenditure(as % of GDP) of Yemen, Rep. in 2009?
Provide a succinct answer. 1.58. What is the difference between the Expenditure(as % of GDP) of Faeroe Islands in 2008 and the Expenditure(as % of GDP) of Zambia in 2009?
Provide a succinct answer. 5.39. What is the difference between the Expenditure(as % of GDP) of Mali in 2008 and the Expenditure(as % of GDP) of Yemen, Rep. in 2009?
Give a very brief answer. 0.86. What is the difference between the Expenditure(as % of GDP) of Mali in 2008 and the Expenditure(as % of GDP) of Zambia in 2009?
Keep it short and to the point. 4.66. What is the difference between the Expenditure(as % of GDP) of Yemen, Rep. in 2008 and the Expenditure(as % of GDP) of Zambia in 2009?
Provide a succinct answer. 4.37. What is the difference between the Expenditure(as % of GDP) of Faeroe Islands in 2008 and the Expenditure(as % of GDP) of Mali in 2010?
Your answer should be very brief. 0.56. What is the difference between the Expenditure(as % of GDP) in Faeroe Islands in 2008 and the Expenditure(as % of GDP) in Yemen, Rep. in 2010?
Your answer should be compact. 0.72. What is the difference between the Expenditure(as % of GDP) of Faeroe Islands in 2008 and the Expenditure(as % of GDP) of Zambia in 2010?
Your answer should be compact. 5.44. What is the difference between the Expenditure(as % of GDP) in Mali in 2008 and the Expenditure(as % of GDP) in Yemen, Rep. in 2010?
Offer a very short reply. -0. What is the difference between the Expenditure(as % of GDP) of Mali in 2008 and the Expenditure(as % of GDP) of Zambia in 2010?
Keep it short and to the point. 4.72. What is the difference between the Expenditure(as % of GDP) in Yemen, Rep. in 2008 and the Expenditure(as % of GDP) in Zambia in 2010?
Ensure brevity in your answer.  4.42. What is the difference between the Expenditure(as % of GDP) in Faeroe Islands in 2009 and the Expenditure(as % of GDP) in Mali in 2010?
Your answer should be compact. 1.04. What is the difference between the Expenditure(as % of GDP) in Faeroe Islands in 2009 and the Expenditure(as % of GDP) in Yemen, Rep. in 2010?
Your response must be concise. 1.21. What is the difference between the Expenditure(as % of GDP) of Faeroe Islands in 2009 and the Expenditure(as % of GDP) of Zambia in 2010?
Offer a terse response. 5.93. What is the difference between the Expenditure(as % of GDP) in Mali in 2009 and the Expenditure(as % of GDP) in Yemen, Rep. in 2010?
Your answer should be very brief. 0.12. What is the difference between the Expenditure(as % of GDP) in Mali in 2009 and the Expenditure(as % of GDP) in Zambia in 2010?
Offer a very short reply. 4.85. What is the difference between the Expenditure(as % of GDP) in Yemen, Rep. in 2009 and the Expenditure(as % of GDP) in Zambia in 2010?
Provide a short and direct response. 3.86. What is the average Expenditure(as % of GDP) in Faeroe Islands per year?
Ensure brevity in your answer.  5.01. What is the average Expenditure(as % of GDP) of Mali per year?
Provide a short and direct response. 4.32. What is the average Expenditure(as % of GDP) of Yemen, Rep. per year?
Provide a short and direct response. 6.28. What is the average Expenditure(as % of GDP) in Zambia per year?
Your response must be concise. 0.44. In the year 2003, what is the difference between the Expenditure(as % of GDP) of Faeroe Islands and Expenditure(as % of GDP) of Mali?
Your answer should be compact. -0.66. In the year 2003, what is the difference between the Expenditure(as % of GDP) in Faeroe Islands and Expenditure(as % of GDP) in Yemen, Rep.?
Offer a very short reply. -7.8. In the year 2003, what is the difference between the Expenditure(as % of GDP) of Faeroe Islands and Expenditure(as % of GDP) of Zambia?
Make the answer very short. 2.24. In the year 2003, what is the difference between the Expenditure(as % of GDP) of Mali and Expenditure(as % of GDP) of Yemen, Rep.?
Provide a succinct answer. -7.14. In the year 2003, what is the difference between the Expenditure(as % of GDP) of Mali and Expenditure(as % of GDP) of Zambia?
Offer a very short reply. 2.9. In the year 2003, what is the difference between the Expenditure(as % of GDP) in Yemen, Rep. and Expenditure(as % of GDP) in Zambia?
Provide a short and direct response. 10.04. In the year 2005, what is the difference between the Expenditure(as % of GDP) in Faeroe Islands and Expenditure(as % of GDP) in Mali?
Your response must be concise. 1.41. In the year 2005, what is the difference between the Expenditure(as % of GDP) in Faeroe Islands and Expenditure(as % of GDP) in Yemen, Rep.?
Your answer should be compact. -3.02. In the year 2005, what is the difference between the Expenditure(as % of GDP) in Faeroe Islands and Expenditure(as % of GDP) in Zambia?
Keep it short and to the point. 4. In the year 2005, what is the difference between the Expenditure(as % of GDP) in Mali and Expenditure(as % of GDP) in Yemen, Rep.?
Keep it short and to the point. -4.43. In the year 2005, what is the difference between the Expenditure(as % of GDP) of Mali and Expenditure(as % of GDP) of Zambia?
Your answer should be compact. 2.6. In the year 2005, what is the difference between the Expenditure(as % of GDP) of Yemen, Rep. and Expenditure(as % of GDP) of Zambia?
Make the answer very short. 7.02. In the year 2006, what is the difference between the Expenditure(as % of GDP) of Faeroe Islands and Expenditure(as % of GDP) of Mali?
Offer a terse response. 1.06. In the year 2006, what is the difference between the Expenditure(as % of GDP) of Faeroe Islands and Expenditure(as % of GDP) of Yemen, Rep.?
Offer a very short reply. -2.2. In the year 2006, what is the difference between the Expenditure(as % of GDP) in Faeroe Islands and Expenditure(as % of GDP) in Zambia?
Provide a succinct answer. 4.07. In the year 2006, what is the difference between the Expenditure(as % of GDP) of Mali and Expenditure(as % of GDP) of Yemen, Rep.?
Provide a short and direct response. -3.26. In the year 2006, what is the difference between the Expenditure(as % of GDP) of Mali and Expenditure(as % of GDP) of Zambia?
Provide a succinct answer. 3.01. In the year 2006, what is the difference between the Expenditure(as % of GDP) of Yemen, Rep. and Expenditure(as % of GDP) of Zambia?
Offer a very short reply. 6.27. In the year 2007, what is the difference between the Expenditure(as % of GDP) in Faeroe Islands and Expenditure(as % of GDP) in Mali?
Offer a very short reply. -0.02. In the year 2007, what is the difference between the Expenditure(as % of GDP) in Faeroe Islands and Expenditure(as % of GDP) in Yemen, Rep.?
Give a very brief answer. -0.36. In the year 2007, what is the difference between the Expenditure(as % of GDP) in Faeroe Islands and Expenditure(as % of GDP) in Zambia?
Provide a short and direct response. 4.37. In the year 2007, what is the difference between the Expenditure(as % of GDP) of Mali and Expenditure(as % of GDP) of Yemen, Rep.?
Offer a terse response. -0.34. In the year 2007, what is the difference between the Expenditure(as % of GDP) in Mali and Expenditure(as % of GDP) in Zambia?
Your response must be concise. 4.39. In the year 2007, what is the difference between the Expenditure(as % of GDP) of Yemen, Rep. and Expenditure(as % of GDP) of Zambia?
Provide a succinct answer. 4.73. In the year 2008, what is the difference between the Expenditure(as % of GDP) in Faeroe Islands and Expenditure(as % of GDP) in Mali?
Provide a succinct answer. 0.73. In the year 2008, what is the difference between the Expenditure(as % of GDP) of Faeroe Islands and Expenditure(as % of GDP) of Yemen, Rep.?
Provide a succinct answer. 1.02. In the year 2008, what is the difference between the Expenditure(as % of GDP) of Faeroe Islands and Expenditure(as % of GDP) of Zambia?
Keep it short and to the point. 5.28. In the year 2008, what is the difference between the Expenditure(as % of GDP) in Mali and Expenditure(as % of GDP) in Yemen, Rep.?
Your answer should be very brief. 0.29. In the year 2008, what is the difference between the Expenditure(as % of GDP) of Mali and Expenditure(as % of GDP) of Zambia?
Your answer should be compact. 4.55. In the year 2008, what is the difference between the Expenditure(as % of GDP) of Yemen, Rep. and Expenditure(as % of GDP) of Zambia?
Provide a succinct answer. 4.26. In the year 2009, what is the difference between the Expenditure(as % of GDP) of Faeroe Islands and Expenditure(as % of GDP) of Mali?
Provide a short and direct response. 1.09. In the year 2009, what is the difference between the Expenditure(as % of GDP) of Faeroe Islands and Expenditure(as % of GDP) of Yemen, Rep.?
Your answer should be very brief. 2.07. In the year 2009, what is the difference between the Expenditure(as % of GDP) in Faeroe Islands and Expenditure(as % of GDP) in Zambia?
Offer a terse response. 5.88. In the year 2009, what is the difference between the Expenditure(as % of GDP) in Mali and Expenditure(as % of GDP) in Yemen, Rep.?
Make the answer very short. 0.99. In the year 2009, what is the difference between the Expenditure(as % of GDP) of Mali and Expenditure(as % of GDP) of Zambia?
Offer a very short reply. 4.79. In the year 2009, what is the difference between the Expenditure(as % of GDP) in Yemen, Rep. and Expenditure(as % of GDP) in Zambia?
Offer a very short reply. 3.81. In the year 2010, what is the difference between the Expenditure(as % of GDP) in Faeroe Islands and Expenditure(as % of GDP) in Mali?
Your answer should be compact. 1.26. In the year 2010, what is the difference between the Expenditure(as % of GDP) of Faeroe Islands and Expenditure(as % of GDP) of Yemen, Rep.?
Keep it short and to the point. 1.42. In the year 2010, what is the difference between the Expenditure(as % of GDP) of Faeroe Islands and Expenditure(as % of GDP) of Zambia?
Offer a very short reply. 6.15. In the year 2010, what is the difference between the Expenditure(as % of GDP) of Mali and Expenditure(as % of GDP) of Yemen, Rep.?
Give a very brief answer. 0.17. In the year 2010, what is the difference between the Expenditure(as % of GDP) of Mali and Expenditure(as % of GDP) of Zambia?
Offer a terse response. 4.89. In the year 2010, what is the difference between the Expenditure(as % of GDP) in Yemen, Rep. and Expenditure(as % of GDP) in Zambia?
Offer a terse response. 4.72. What is the ratio of the Expenditure(as % of GDP) of Faeroe Islands in 2003 to that in 2005?
Provide a succinct answer. 0.64. What is the ratio of the Expenditure(as % of GDP) of Mali in 2003 to that in 2005?
Make the answer very short. 1.13. What is the ratio of the Expenditure(as % of GDP) of Yemen, Rep. in 2003 to that in 2005?
Keep it short and to the point. 1.41. What is the ratio of the Expenditure(as % of GDP) of Zambia in 2003 to that in 2005?
Provide a short and direct response. 1.17. What is the ratio of the Expenditure(as % of GDP) of Faeroe Islands in 2003 to that in 2006?
Your answer should be compact. 0.66. What is the ratio of the Expenditure(as % of GDP) of Mali in 2003 to that in 2006?
Give a very brief answer. 1.05. What is the ratio of the Expenditure(as % of GDP) of Yemen, Rep. in 2003 to that in 2006?
Provide a succinct answer. 1.6. What is the ratio of the Expenditure(as % of GDP) of Zambia in 2003 to that in 2006?
Ensure brevity in your answer.  1.64. What is the ratio of the Expenditure(as % of GDP) in Faeroe Islands in 2003 to that in 2007?
Offer a very short reply. 0.62. What is the ratio of the Expenditure(as % of GDP) of Mali in 2003 to that in 2007?
Give a very brief answer. 0.76. What is the ratio of the Expenditure(as % of GDP) of Yemen, Rep. in 2003 to that in 2007?
Your response must be concise. 2.09. What is the ratio of the Expenditure(as % of GDP) in Zambia in 2003 to that in 2007?
Your answer should be compact. 1.76. What is the ratio of the Expenditure(as % of GDP) of Faeroe Islands in 2003 to that in 2008?
Give a very brief answer. 0.53. What is the ratio of the Expenditure(as % of GDP) in Mali in 2003 to that in 2008?
Your answer should be compact. 0.74. What is the ratio of the Expenditure(as % of GDP) of Yemen, Rep. in 2003 to that in 2008?
Your response must be concise. 2.32. What is the ratio of the Expenditure(as % of GDP) of Zambia in 2003 to that in 2008?
Provide a succinct answer. 1.95. What is the ratio of the Expenditure(as % of GDP) of Faeroe Islands in 2003 to that in 2009?
Your response must be concise. 0.49. What is the ratio of the Expenditure(as % of GDP) of Mali in 2003 to that in 2009?
Offer a terse response. 0.72. What is the ratio of the Expenditure(as % of GDP) in Yemen, Rep. in 2003 to that in 2009?
Provide a short and direct response. 2.65. What is the ratio of the Expenditure(as % of GDP) of Zambia in 2003 to that in 2009?
Your answer should be very brief. 2.75. What is the ratio of the Expenditure(as % of GDP) of Faeroe Islands in 2003 to that in 2010?
Offer a terse response. 0.47. What is the ratio of the Expenditure(as % of GDP) in Mali in 2003 to that in 2010?
Ensure brevity in your answer.  0.71. What is the ratio of the Expenditure(as % of GDP) in Yemen, Rep. in 2003 to that in 2010?
Offer a terse response. 2.18. What is the ratio of the Expenditure(as % of GDP) of Zambia in 2003 to that in 2010?
Your response must be concise. 3.44. What is the ratio of the Expenditure(as % of GDP) of Faeroe Islands in 2005 to that in 2006?
Make the answer very short. 1.03. What is the ratio of the Expenditure(as % of GDP) of Mali in 2005 to that in 2006?
Offer a terse response. 0.93. What is the ratio of the Expenditure(as % of GDP) of Yemen, Rep. in 2005 to that in 2006?
Ensure brevity in your answer.  1.14. What is the ratio of the Expenditure(as % of GDP) of Zambia in 2005 to that in 2006?
Offer a very short reply. 1.4. What is the ratio of the Expenditure(as % of GDP) of Faeroe Islands in 2005 to that in 2007?
Provide a succinct answer. 0.97. What is the ratio of the Expenditure(as % of GDP) in Mali in 2005 to that in 2007?
Offer a terse response. 0.67. What is the ratio of the Expenditure(as % of GDP) of Yemen, Rep. in 2005 to that in 2007?
Provide a succinct answer. 1.49. What is the ratio of the Expenditure(as % of GDP) of Zambia in 2005 to that in 2007?
Offer a terse response. 1.5. What is the ratio of the Expenditure(as % of GDP) of Faeroe Islands in 2005 to that in 2008?
Provide a short and direct response. 0.82. What is the ratio of the Expenditure(as % of GDP) of Mali in 2005 to that in 2008?
Your answer should be very brief. 0.65. What is the ratio of the Expenditure(as % of GDP) in Yemen, Rep. in 2005 to that in 2008?
Offer a very short reply. 1.65. What is the ratio of the Expenditure(as % of GDP) of Zambia in 2005 to that in 2008?
Your answer should be compact. 1.67. What is the ratio of the Expenditure(as % of GDP) in Faeroe Islands in 2005 to that in 2009?
Give a very brief answer. 0.75. What is the ratio of the Expenditure(as % of GDP) of Mali in 2005 to that in 2009?
Your answer should be very brief. 0.64. What is the ratio of the Expenditure(as % of GDP) of Yemen, Rep. in 2005 to that in 2009?
Provide a succinct answer. 1.88. What is the ratio of the Expenditure(as % of GDP) of Zambia in 2005 to that in 2009?
Provide a short and direct response. 2.36. What is the ratio of the Expenditure(as % of GDP) in Faeroe Islands in 2005 to that in 2010?
Ensure brevity in your answer.  0.73. What is the ratio of the Expenditure(as % of GDP) in Mali in 2005 to that in 2010?
Your answer should be compact. 0.63. What is the ratio of the Expenditure(as % of GDP) of Yemen, Rep. in 2005 to that in 2010?
Ensure brevity in your answer.  1.55. What is the ratio of the Expenditure(as % of GDP) in Zambia in 2005 to that in 2010?
Provide a succinct answer. 2.95. What is the ratio of the Expenditure(as % of GDP) of Faeroe Islands in 2006 to that in 2007?
Provide a succinct answer. 0.94. What is the ratio of the Expenditure(as % of GDP) of Mali in 2006 to that in 2007?
Make the answer very short. 0.72. What is the ratio of the Expenditure(as % of GDP) in Yemen, Rep. in 2006 to that in 2007?
Offer a terse response. 1.3. What is the ratio of the Expenditure(as % of GDP) in Zambia in 2006 to that in 2007?
Your answer should be compact. 1.07. What is the ratio of the Expenditure(as % of GDP) of Faeroe Islands in 2006 to that in 2008?
Provide a short and direct response. 0.8. What is the ratio of the Expenditure(as % of GDP) of Mali in 2006 to that in 2008?
Offer a very short reply. 0.7. What is the ratio of the Expenditure(as % of GDP) of Yemen, Rep. in 2006 to that in 2008?
Your response must be concise. 1.45. What is the ratio of the Expenditure(as % of GDP) of Zambia in 2006 to that in 2008?
Keep it short and to the point. 1.19. What is the ratio of the Expenditure(as % of GDP) of Faeroe Islands in 2006 to that in 2009?
Your response must be concise. 0.74. What is the ratio of the Expenditure(as % of GDP) in Mali in 2006 to that in 2009?
Provide a succinct answer. 0.68. What is the ratio of the Expenditure(as % of GDP) in Yemen, Rep. in 2006 to that in 2009?
Your response must be concise. 1.65. What is the ratio of the Expenditure(as % of GDP) in Zambia in 2006 to that in 2009?
Give a very brief answer. 1.68. What is the ratio of the Expenditure(as % of GDP) of Faeroe Islands in 2006 to that in 2010?
Ensure brevity in your answer.  0.71. What is the ratio of the Expenditure(as % of GDP) of Mali in 2006 to that in 2010?
Make the answer very short. 0.68. What is the ratio of the Expenditure(as % of GDP) in Yemen, Rep. in 2006 to that in 2010?
Give a very brief answer. 1.36. What is the ratio of the Expenditure(as % of GDP) of Zambia in 2006 to that in 2010?
Provide a short and direct response. 2.1. What is the ratio of the Expenditure(as % of GDP) of Faeroe Islands in 2007 to that in 2008?
Ensure brevity in your answer.  0.85. What is the ratio of the Expenditure(as % of GDP) in Mali in 2007 to that in 2008?
Your response must be concise. 0.98. What is the ratio of the Expenditure(as % of GDP) in Yemen, Rep. in 2007 to that in 2008?
Offer a terse response. 1.11. What is the ratio of the Expenditure(as % of GDP) of Zambia in 2007 to that in 2008?
Your answer should be compact. 1.11. What is the ratio of the Expenditure(as % of GDP) in Faeroe Islands in 2007 to that in 2009?
Offer a terse response. 0.78. What is the ratio of the Expenditure(as % of GDP) of Mali in 2007 to that in 2009?
Provide a succinct answer. 0.95. What is the ratio of the Expenditure(as % of GDP) of Yemen, Rep. in 2007 to that in 2009?
Provide a succinct answer. 1.26. What is the ratio of the Expenditure(as % of GDP) in Zambia in 2007 to that in 2009?
Your answer should be very brief. 1.57. What is the ratio of the Expenditure(as % of GDP) in Faeroe Islands in 2007 to that in 2010?
Provide a short and direct response. 0.75. What is the ratio of the Expenditure(as % of GDP) in Mali in 2007 to that in 2010?
Make the answer very short. 0.94. What is the ratio of the Expenditure(as % of GDP) of Yemen, Rep. in 2007 to that in 2010?
Provide a short and direct response. 1.04. What is the ratio of the Expenditure(as % of GDP) of Zambia in 2007 to that in 2010?
Provide a succinct answer. 1.96. What is the ratio of the Expenditure(as % of GDP) in Faeroe Islands in 2008 to that in 2009?
Your answer should be very brief. 0.92. What is the ratio of the Expenditure(as % of GDP) of Mali in 2008 to that in 2009?
Provide a short and direct response. 0.97. What is the ratio of the Expenditure(as % of GDP) of Yemen, Rep. in 2008 to that in 2009?
Offer a terse response. 1.14. What is the ratio of the Expenditure(as % of GDP) of Zambia in 2008 to that in 2009?
Offer a very short reply. 1.41. What is the ratio of the Expenditure(as % of GDP) in Faeroe Islands in 2008 to that in 2010?
Your response must be concise. 0.89. What is the ratio of the Expenditure(as % of GDP) of Mali in 2008 to that in 2010?
Offer a terse response. 0.97. What is the ratio of the Expenditure(as % of GDP) of Yemen, Rep. in 2008 to that in 2010?
Provide a succinct answer. 0.94. What is the ratio of the Expenditure(as % of GDP) of Zambia in 2008 to that in 2010?
Your answer should be very brief. 1.77. What is the ratio of the Expenditure(as % of GDP) of Faeroe Islands in 2009 to that in 2010?
Keep it short and to the point. 0.97. What is the ratio of the Expenditure(as % of GDP) of Yemen, Rep. in 2009 to that in 2010?
Your answer should be very brief. 0.83. What is the ratio of the Expenditure(as % of GDP) of Zambia in 2009 to that in 2010?
Provide a succinct answer. 1.25. What is the difference between the highest and the second highest Expenditure(as % of GDP) in Faeroe Islands?
Provide a succinct answer. 0.21. What is the difference between the highest and the second highest Expenditure(as % of GDP) in Mali?
Make the answer very short. 0.04. What is the difference between the highest and the second highest Expenditure(as % of GDP) of Yemen, Rep.?
Offer a terse response. 3.13. What is the difference between the highest and the second highest Expenditure(as % of GDP) in Zambia?
Provide a short and direct response. 0.11. What is the difference between the highest and the lowest Expenditure(as % of GDP) in Faeroe Islands?
Your response must be concise. 3.38. What is the difference between the highest and the lowest Expenditure(as % of GDP) of Mali?
Offer a terse response. 1.87. What is the difference between the highest and the lowest Expenditure(as % of GDP) in Yemen, Rep.?
Give a very brief answer. 6.71. What is the difference between the highest and the lowest Expenditure(as % of GDP) of Zambia?
Your answer should be compact. 0.53. 